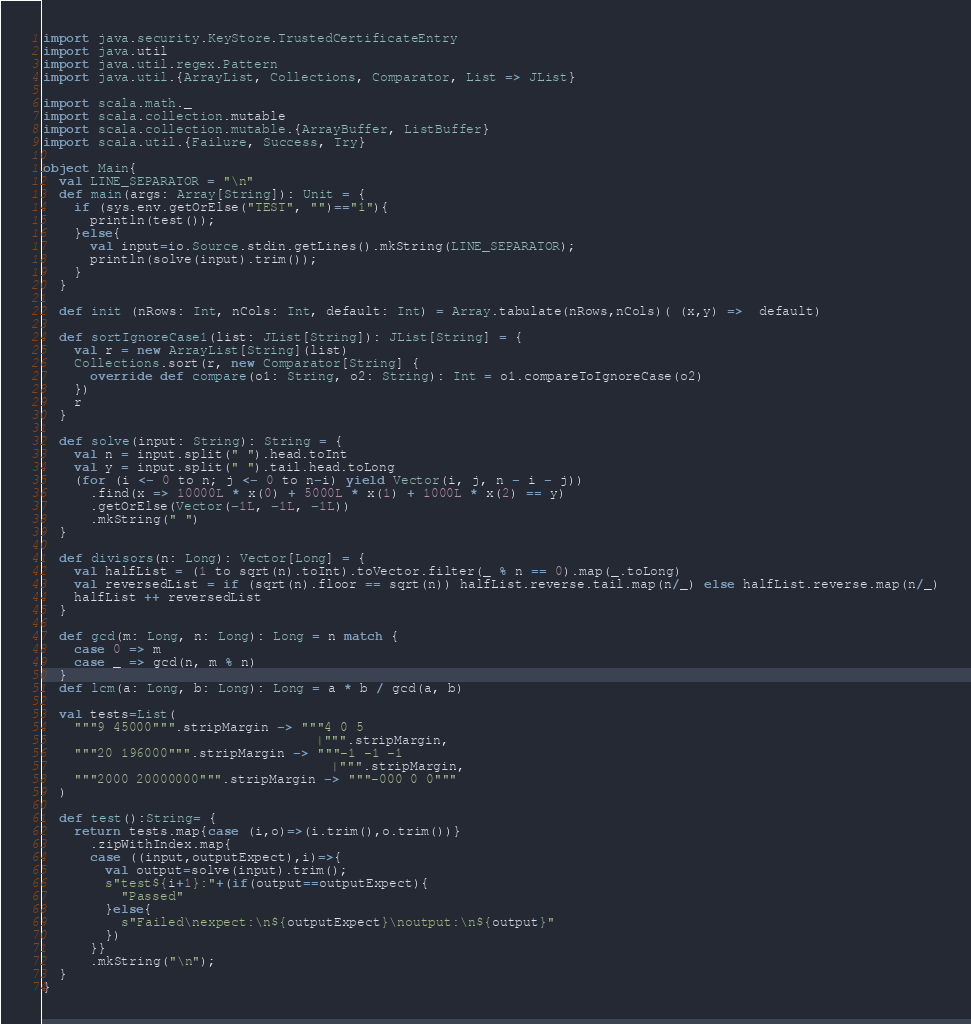Convert code to text. <code><loc_0><loc_0><loc_500><loc_500><_Scala_>import java.security.KeyStore.TrustedCertificateEntry
import java.util
import java.util.regex.Pattern
import java.util.{ArrayList, Collections, Comparator, List => JList}

import scala.math._
import scala.collection.mutable
import scala.collection.mutable.{ArrayBuffer, ListBuffer}
import scala.util.{Failure, Success, Try}

object Main{
  val LINE_SEPARATOR = "\n"
  def main(args: Array[String]): Unit = {
    if (sys.env.getOrElse("TEST", "")=="1"){
      println(test());
    }else{
      val input=io.Source.stdin.getLines().mkString(LINE_SEPARATOR);
      println(solve(input).trim());
    }
  }

  def init (nRows: Int, nCols: Int, default: Int) = Array.tabulate(nRows,nCols)( (x,y) =>  default)

  def sortIgnoreCase1(list: JList[String]): JList[String] = {
    val r = new ArrayList[String](list)
    Collections.sort(r, new Comparator[String] {
      override def compare(o1: String, o2: String): Int = o1.compareToIgnoreCase(o2)
    })
    r
  }

  def solve(input: String): String = {
    val n = input.split(" ").head.toInt
    val y = input.split(" ").tail.head.toLong
    (for (i <- 0 to n; j <- 0 to n-i) yield Vector(i, j, n - i - j))
      .find(x => 10000L * x(0) + 5000L * x(1) + 1000L * x(2) == y)
      .getOrElse(Vector(-1L, -1L, -1L))
      .mkString(" ")
  }

  def divisors(n: Long): Vector[Long] = {
    val halfList = (1 to sqrt(n).toInt).toVector.filter(_ % n == 0).map(_.toLong)
    val reversedList = if (sqrt(n).floor == sqrt(n)) halfList.reverse.tail.map(n/_) else halfList.reverse.map(n/_)
    halfList ++ reversedList
  }

  def gcd(m: Long, n: Long): Long = n match {
    case 0 => m
    case _ => gcd(n, m % n)
  }
  def lcm(a: Long, b: Long): Long = a * b / gcd(a, b)

  val tests=List(
    """9 45000""".stripMargin -> """4 0 5
                                   |""".stripMargin,
    """20 196000""".stripMargin -> """-1 -1 -1
                                     |""".stripMargin,
    """2000 20000000""".stripMargin -> """-000 0 0"""
  )

  def test():String= {
    return tests.map{case (i,o)=>(i.trim(),o.trim())}
      .zipWithIndex.map{
      case ((input,outputExpect),i)=>{
        val output=solve(input).trim();
        s"test${i+1}:"+(if(output==outputExpect){
          "Passed"
        }else{
          s"Failed\nexpect:\n${outputExpect}\noutput:\n${output}"
        })
      }}
      .mkString("\n");
  }
}</code> 